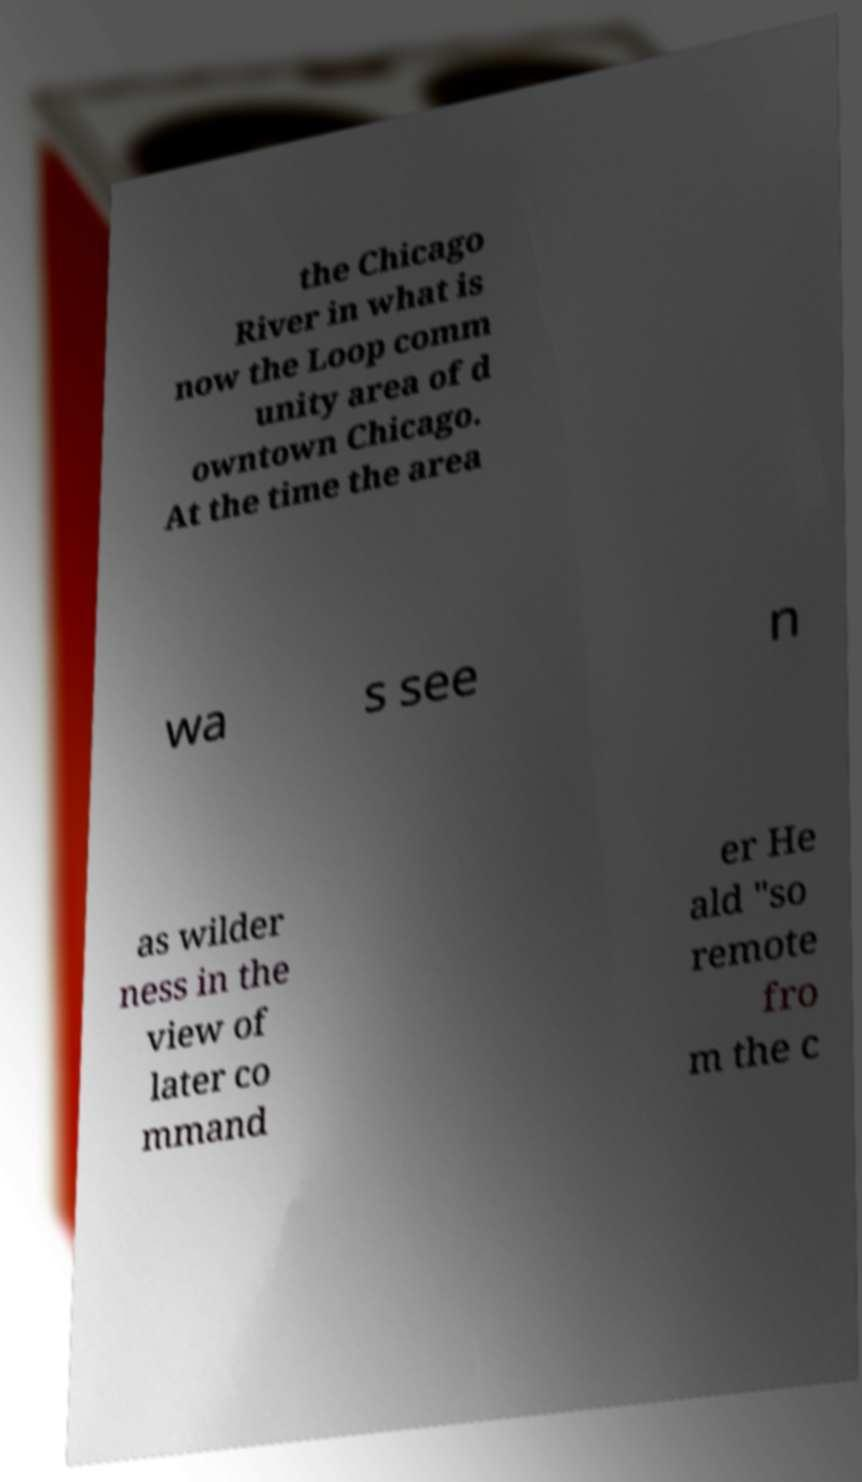Can you accurately transcribe the text from the provided image for me? the Chicago River in what is now the Loop comm unity area of d owntown Chicago. At the time the area wa s see n as wilder ness in the view of later co mmand er He ald "so remote fro m the c 